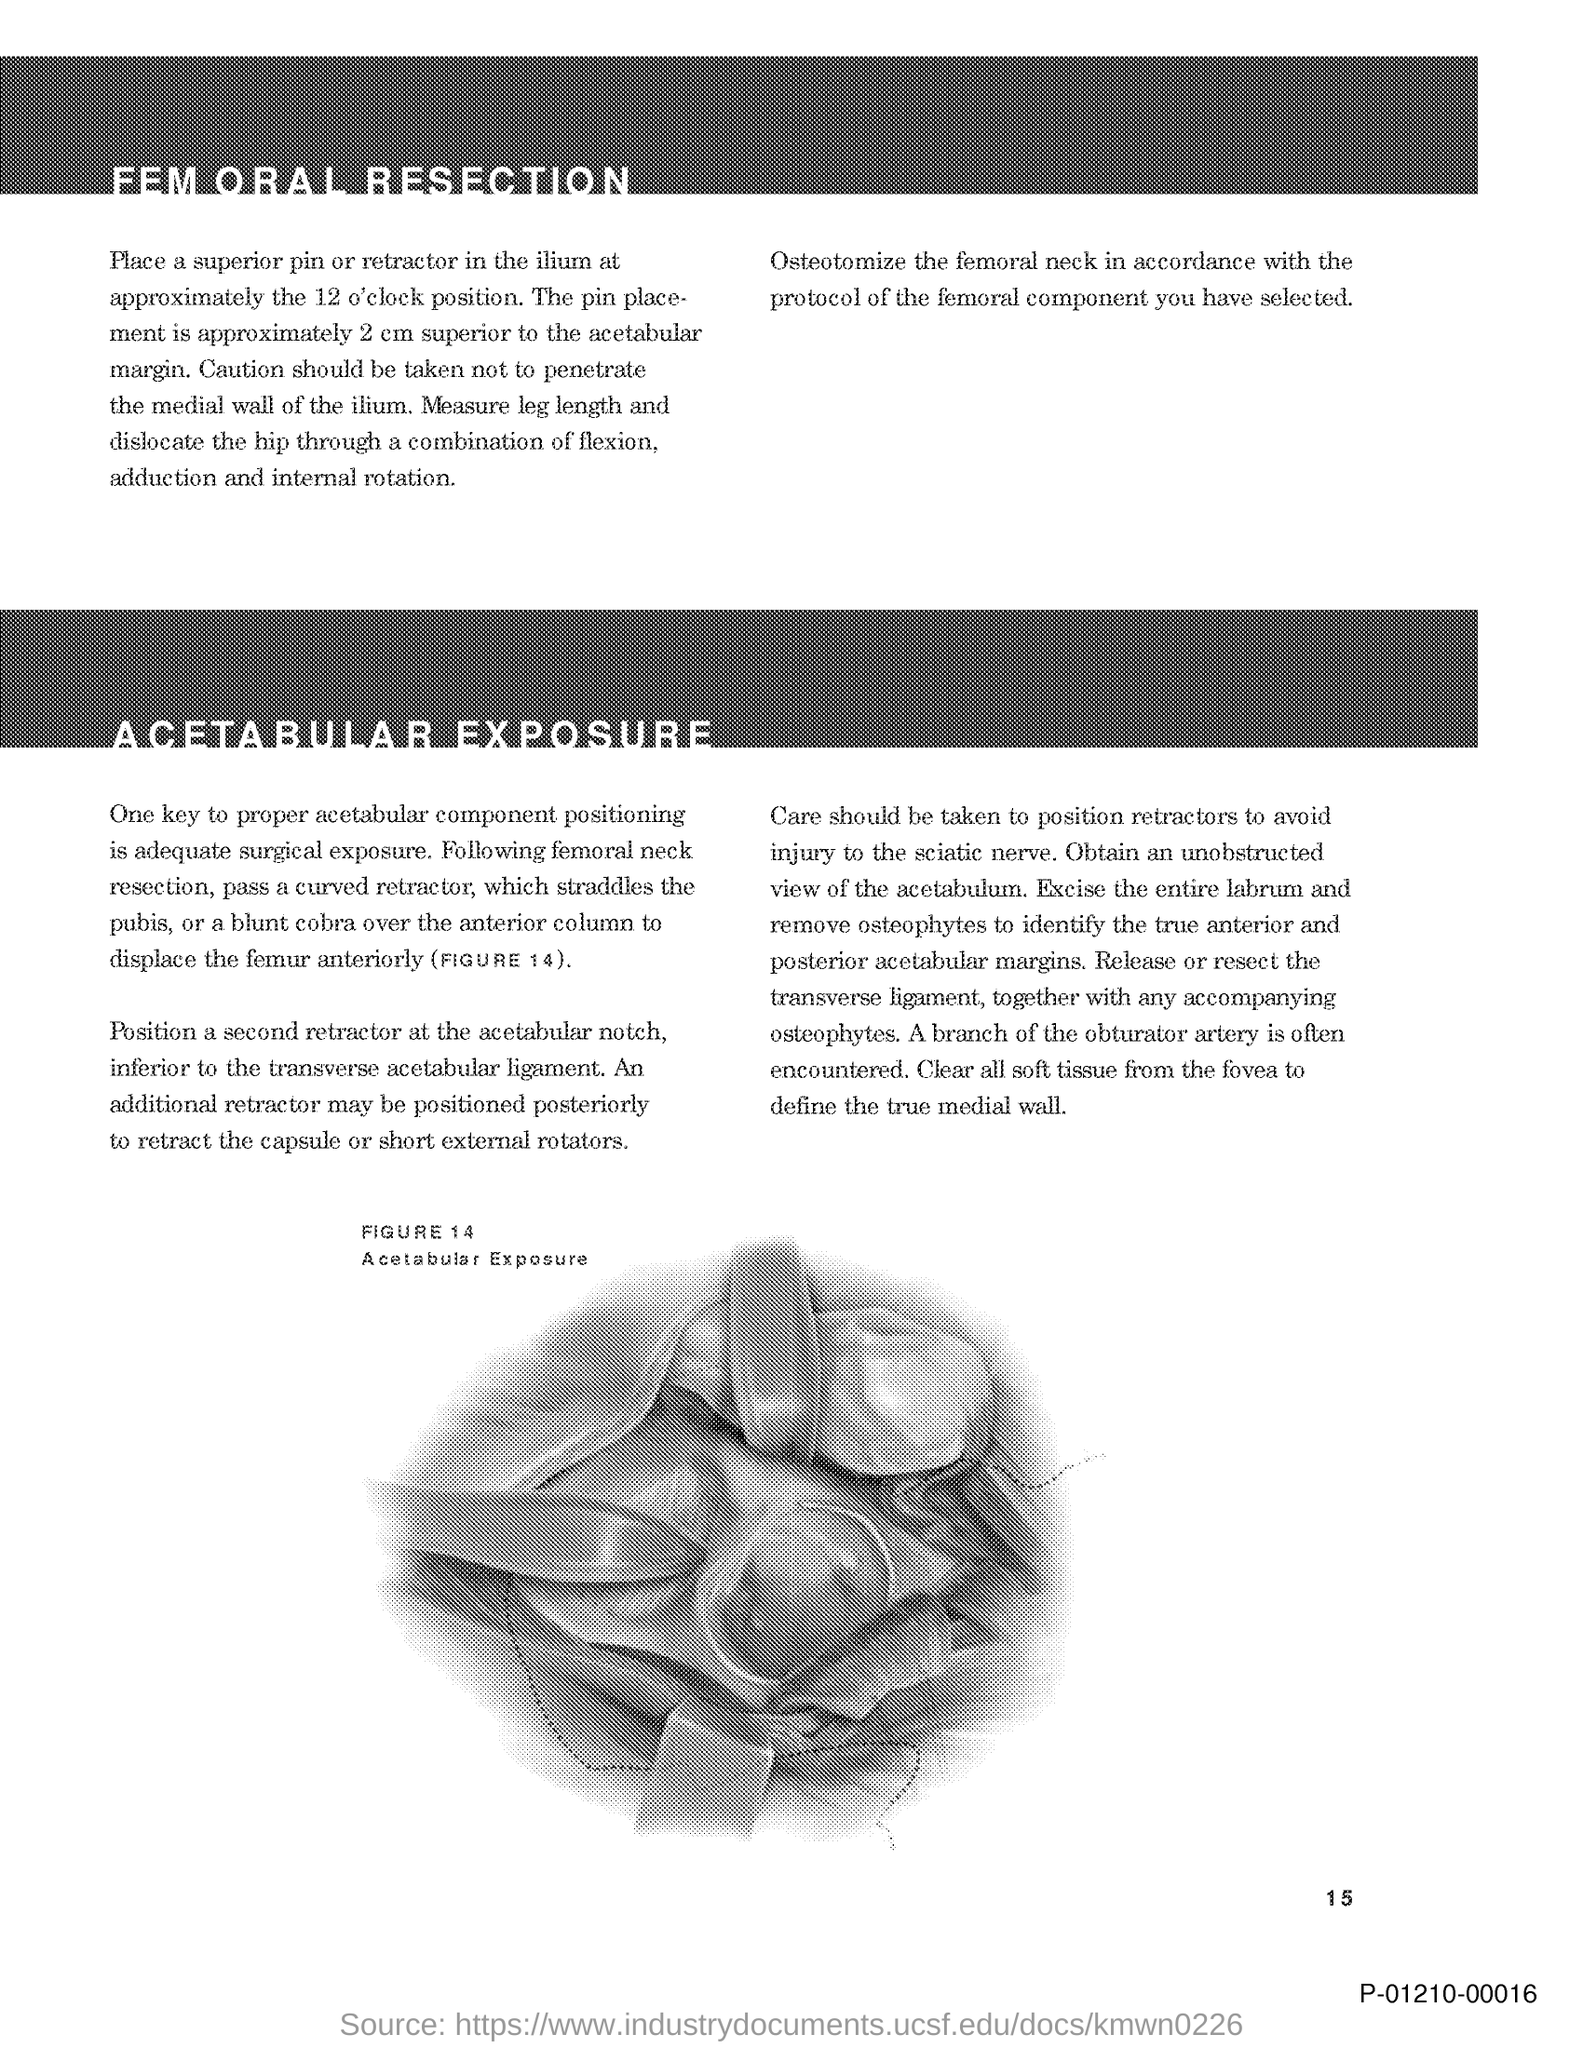What is the page no mentioned in this document? The page number mentioned in this document is 15, as seen at the bottom right corner of the provided image. 